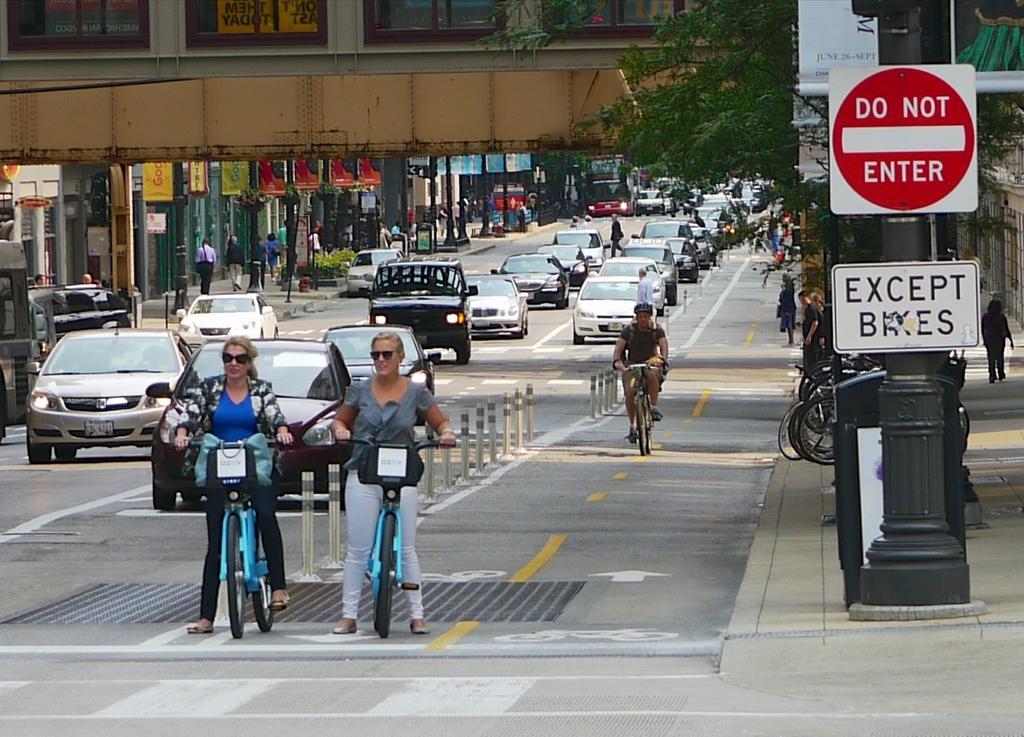Could you give a brief overview of what you see in this image? In this image I can see some vehicles on the road. I can see some people. On the right side, I can see the boards with some text written on it. 